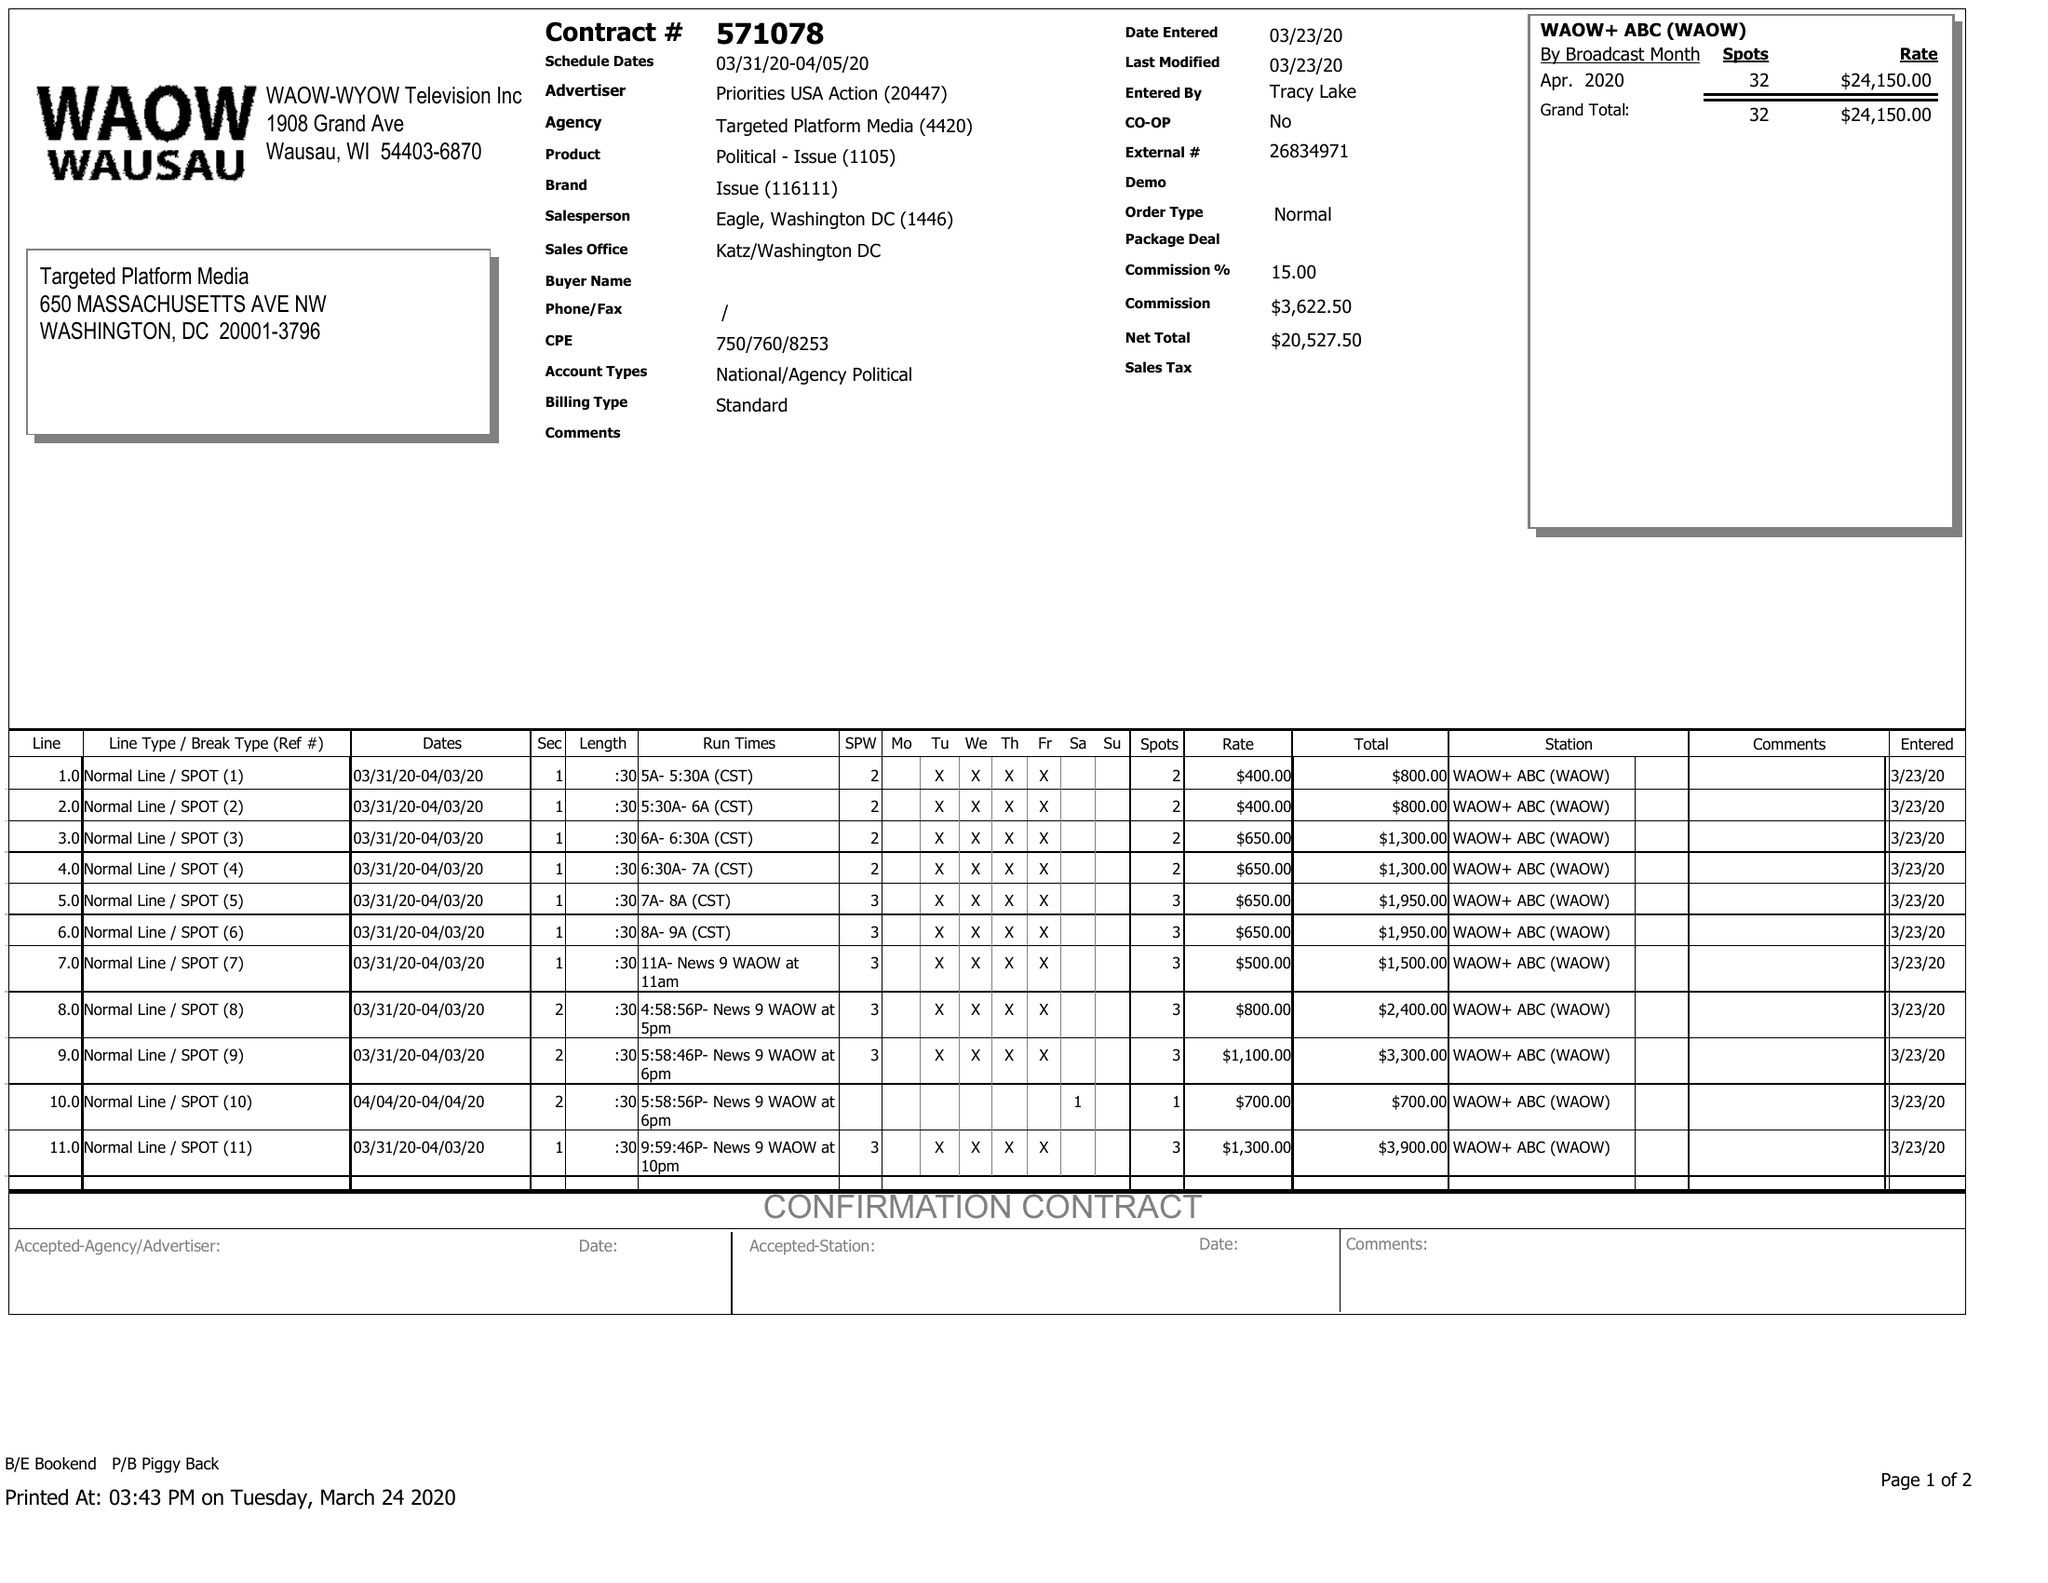What is the value for the advertiser?
Answer the question using a single word or phrase. PRIORITIES USA ACTION 